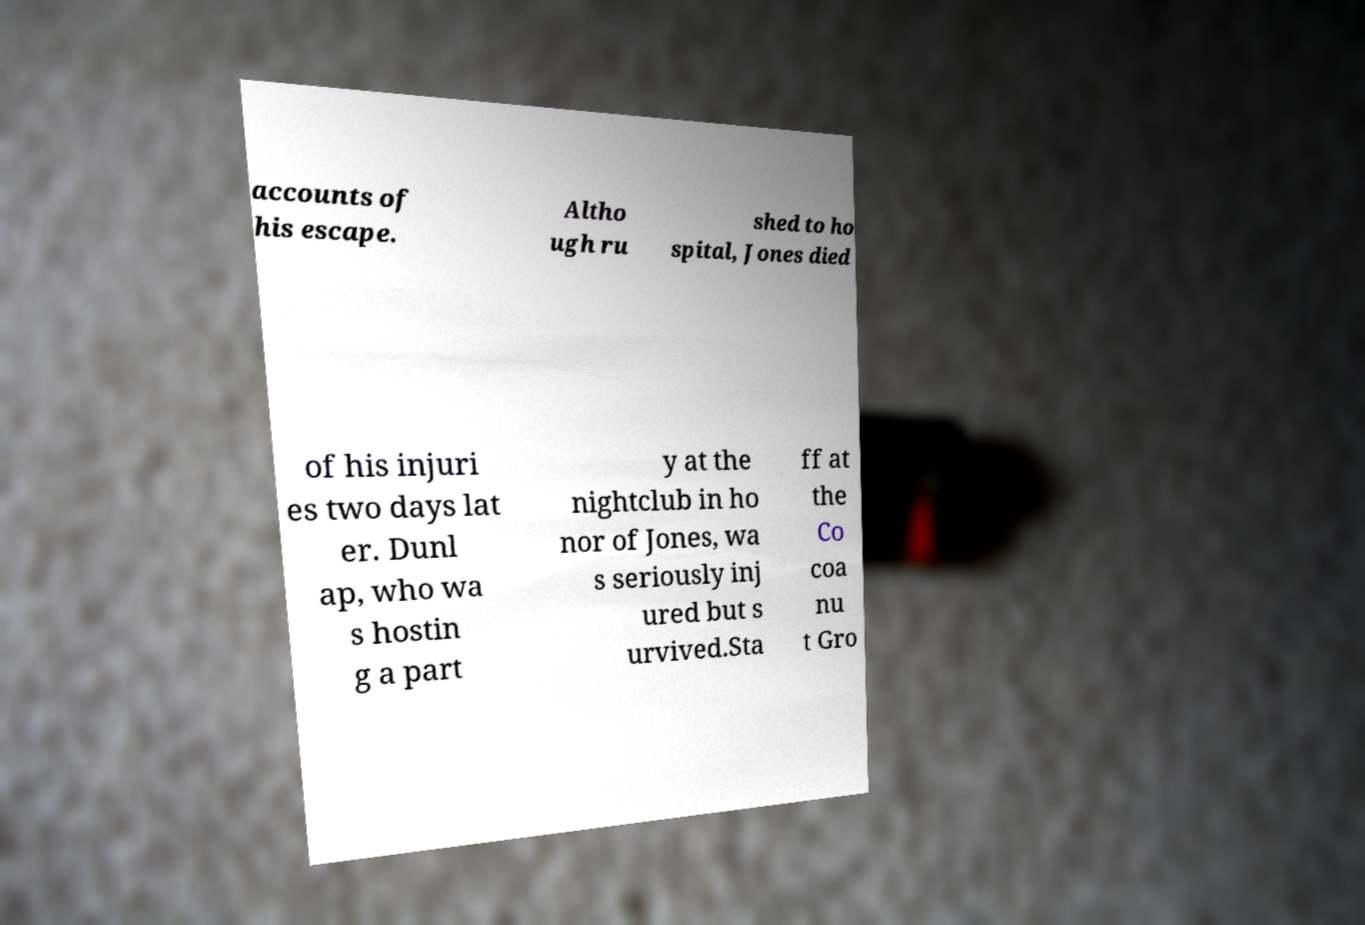For documentation purposes, I need the text within this image transcribed. Could you provide that? accounts of his escape. Altho ugh ru shed to ho spital, Jones died of his injuri es two days lat er. Dunl ap, who wa s hostin g a part y at the nightclub in ho nor of Jones, wa s seriously inj ured but s urvived.Sta ff at the Co coa nu t Gro 